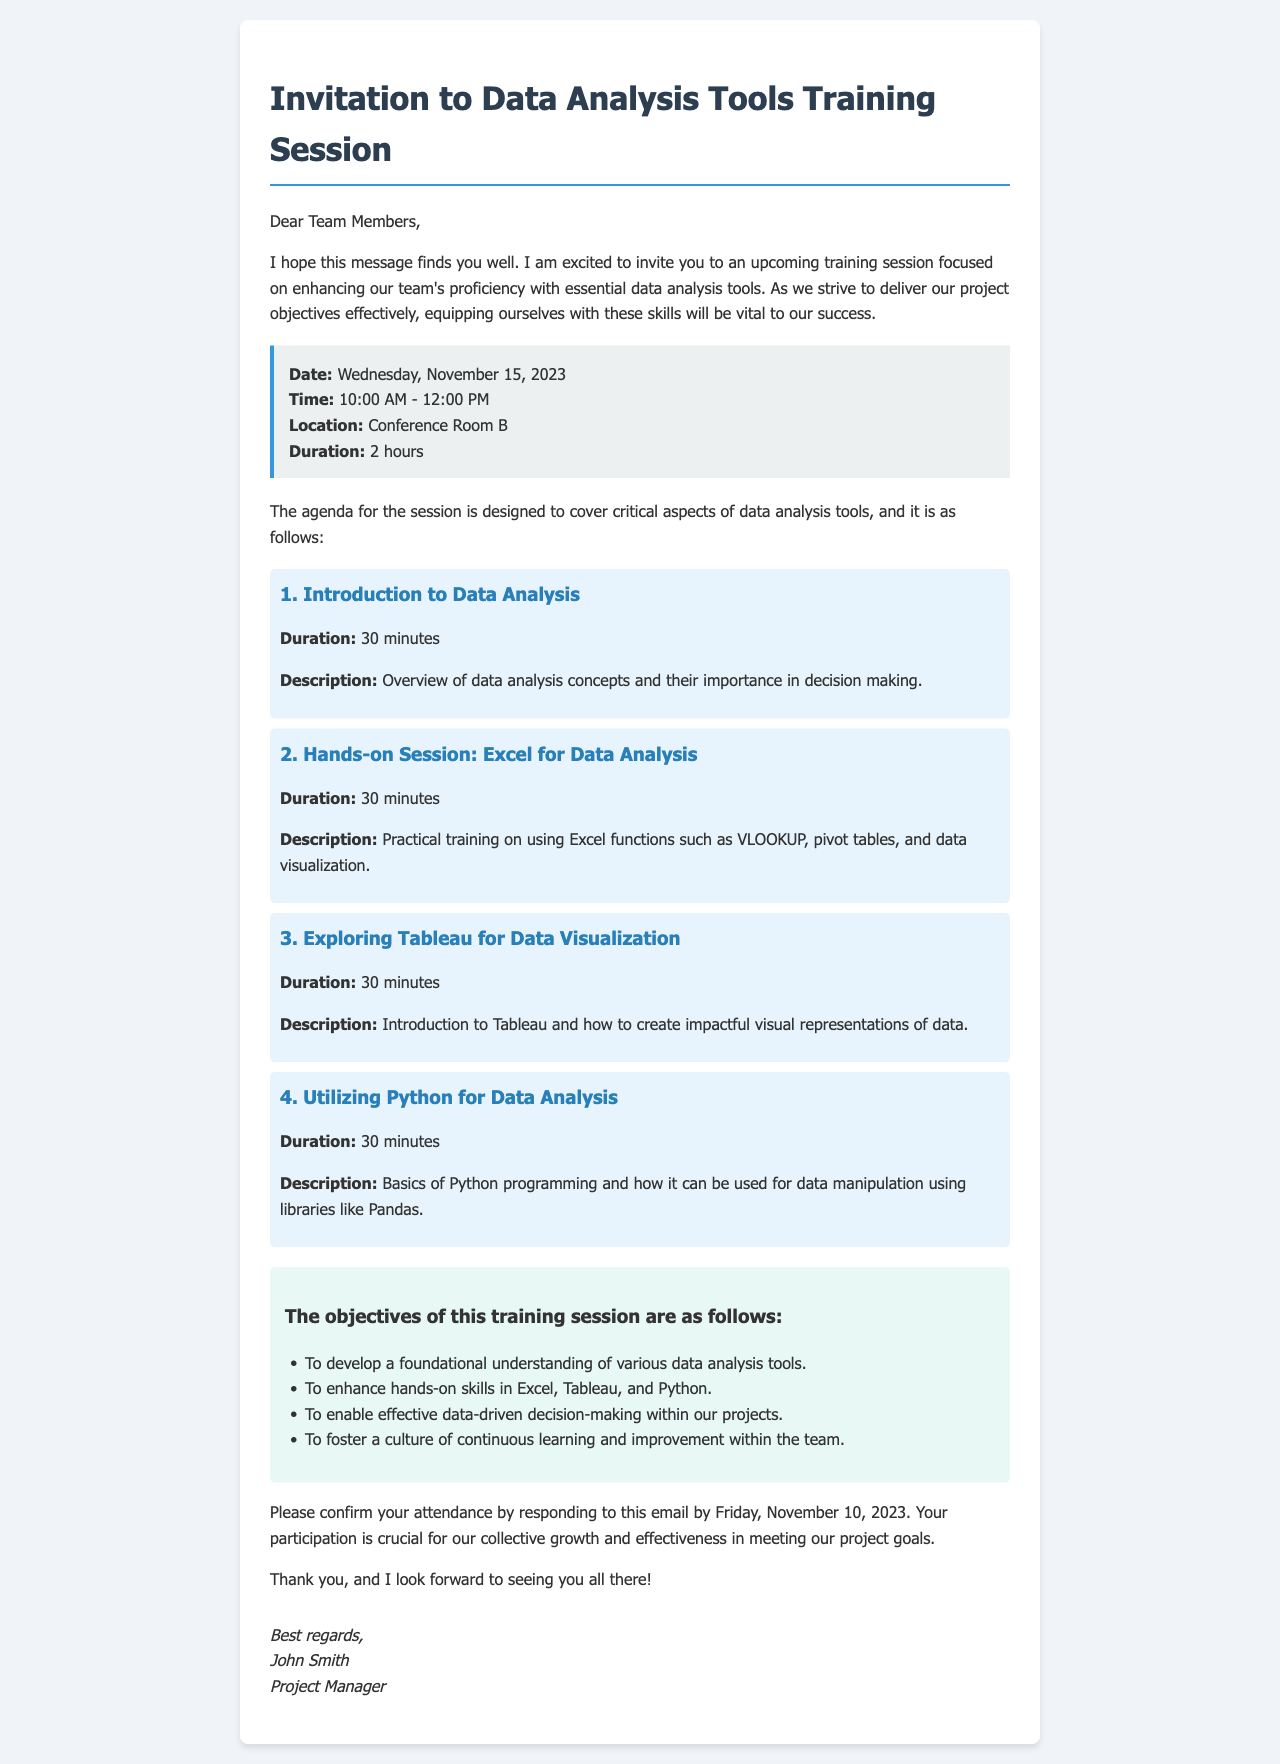What is the date of the training session? The date of the training session is clearly mentioned in the session details section.
Answer: Wednesday, November 15, 2023 What time does the training session start? The start time for the training session is specified along with the duration.
Answer: 10:00 AM Where will the training session take place? The location of the training session is provided in the session details section.
Answer: Conference Room B How long is the training session? The duration of the training session is stated in the session details.
Answer: 2 hours What is the objective related to decision-making? One of the objectives outlines the importance of data-driven decision-making, requiring careful reading of the objectives section.
Answer: To enable effective data-driven decision-making within our projects What tool will be covered first in the agenda? The first agenda item focuses on a general introduction before delving into specific tools.
Answer: Introduction to Data Analysis Who is sending the invitation email? The signature at the end of the email identifies the sender of the invitation.
Answer: John Smith By what date should team members confirm attendance? The deadline for confirming attendance is mentioned in the concluding remarks of the email.
Answer: Friday, November 10, 2023 What is the overarching goal of this training? The overall purpose of the training is hinted at in both the introduction and the objectives.
Answer: Enhancing proficiency with essential data analysis tools 